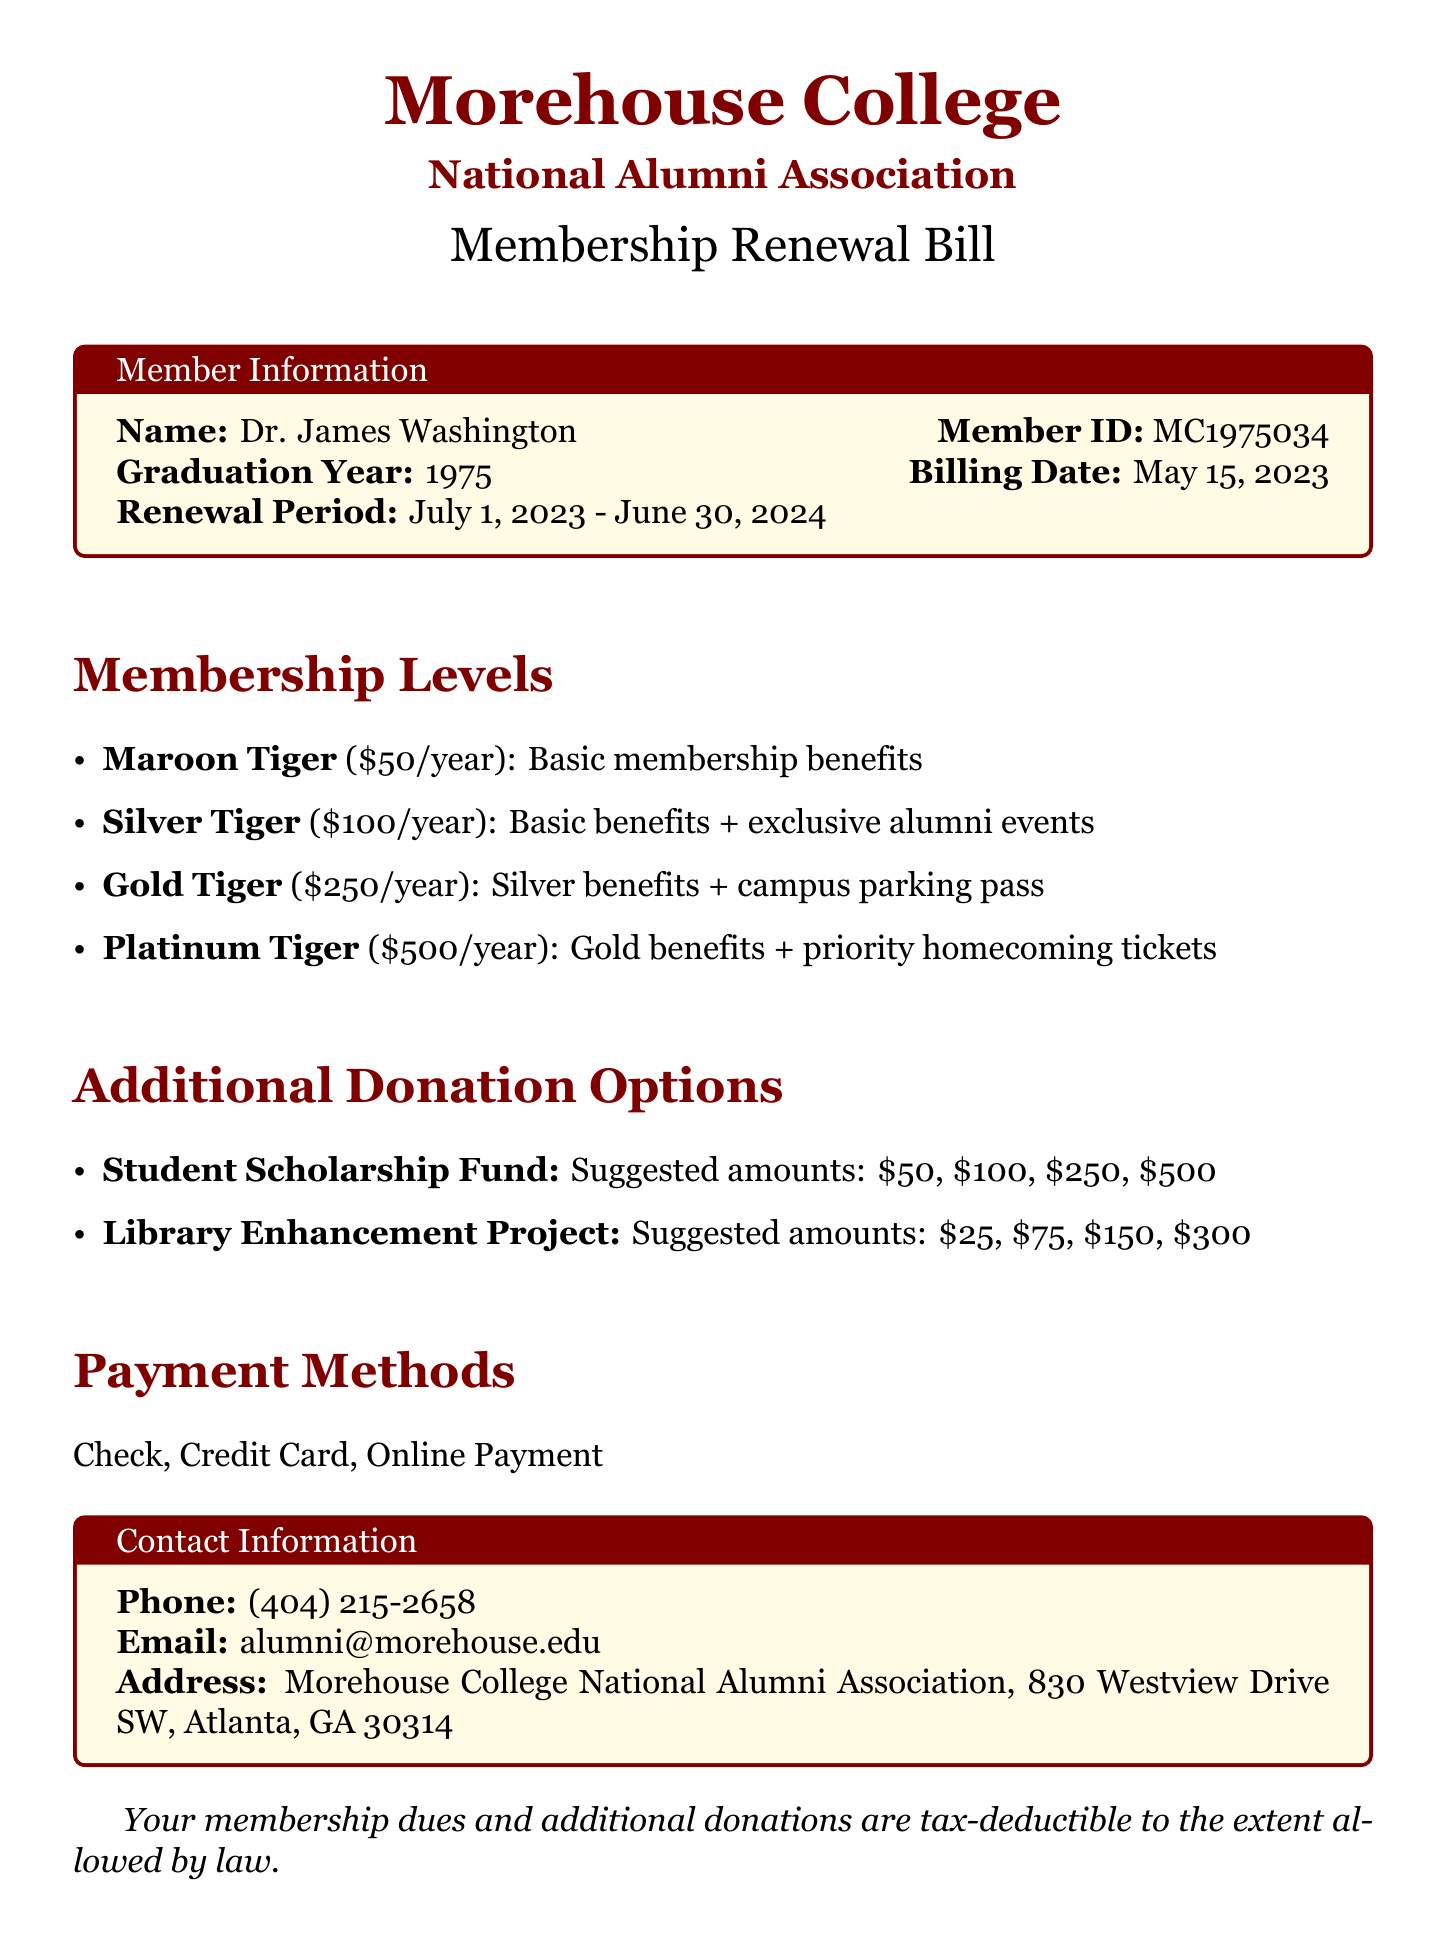What is the name of the association? The document specifies "Morehouse College National Alumni Association" as the association's name.
Answer: Morehouse College National Alumni Association Who is the member? The document lists "Dr. James Washington" as the member's name.
Answer: Dr. James Washington What is the member's ID? The member ID provided in the document is "MC1975034".
Answer: MC1975034 What is the renewal period? The renewal period is expressed in the document as "July 1, 2023 - June 30, 2024".
Answer: July 1, 2023 - June 30, 2024 How much is the Gold Tiger membership? The document states that the Gold Tiger membership costs "$250/year".
Answer: $250/year Which payment methods are available? The document enumerates "Check, Credit Card, Online Payment" as the available payment methods.
Answer: Check, Credit Card, Online Payment What is the highest suggested donation for the Student Scholarship Fund? The document suggests a maximum donation amount of "$500" for the Student Scholarship Fund.
Answer: $500 What are the benefits of the Platinum Tiger membership? The Platinum Tiger membership includes "Gold benefits + priority homecoming tickets".
Answer: Gold benefits + priority homecoming tickets What is the phone contact listed? The document provides the phone contact as "(404) 215-2658".
Answer: (404) 215-2658 